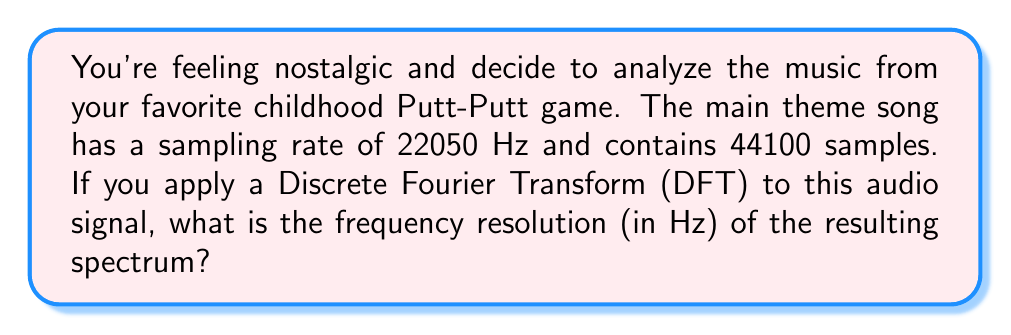Help me with this question. To solve this problem, we need to understand the relationship between the Discrete Fourier Transform (DFT), sampling rate, and number of samples. The frequency resolution in a DFT is determined by these parameters.

1. First, let's recall the formula for frequency resolution in a DFT:

   $$\Delta f = \frac{f_s}{N}$$

   Where:
   $\Delta f$ is the frequency resolution
   $f_s$ is the sampling rate
   $N$ is the number of samples

2. We're given:
   - Sampling rate ($f_s$) = 22050 Hz
   - Number of samples ($N$) = 44100

3. Now, let's substitute these values into our formula:

   $$\Delta f = \frac{22050 \text{ Hz}}{44100}$$

4. Simplify:
   
   $$\Delta f = 0.5 \text{ Hz}$$

This means that each bin in the resulting frequency spectrum represents a 0.5 Hz range. This relatively fine resolution allows for detailed analysis of the frequency components in the retro game music, potentially helping to identify specific instruments or musical elements that contribute to the nostalgic sound of Putt-Putt game music.
Answer: $0.5 \text{ Hz}$ 